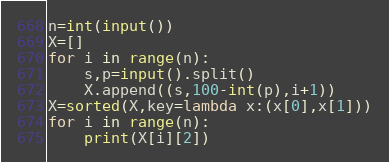<code> <loc_0><loc_0><loc_500><loc_500><_Python_>n=int(input())
X=[]
for i in range(n):
    s,p=input().split()
    X.append((s,100-int(p),i+1))
X=sorted(X,key=lambda x:(x[0],x[1]))
for i in range(n):
    print(X[i][2])</code> 